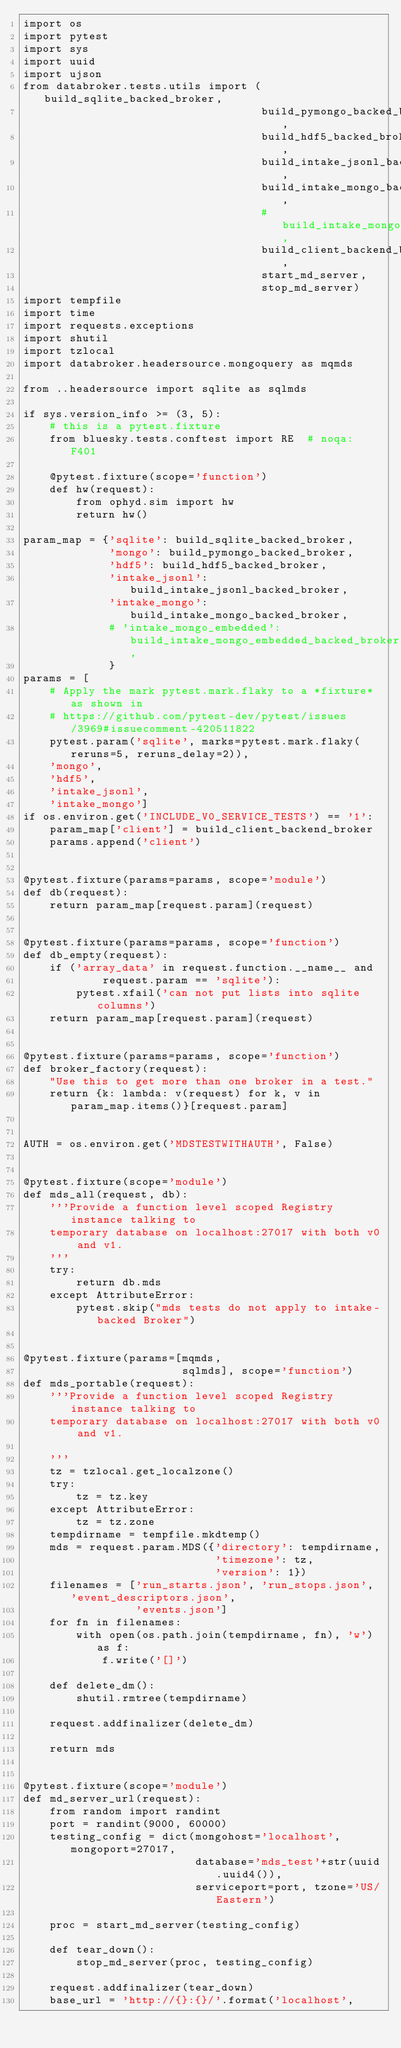<code> <loc_0><loc_0><loc_500><loc_500><_Python_>import os
import pytest
import sys
import uuid
import ujson
from databroker.tests.utils import (build_sqlite_backed_broker,
                                    build_pymongo_backed_broker,
                                    build_hdf5_backed_broker,
                                    build_intake_jsonl_backed_broker,
                                    build_intake_mongo_backed_broker,
                                    # build_intake_mongo_embedded_backed_broker,
                                    build_client_backend_broker,
                                    start_md_server,
                                    stop_md_server)
import tempfile
import time
import requests.exceptions
import shutil
import tzlocal
import databroker.headersource.mongoquery as mqmds

from ..headersource import sqlite as sqlmds

if sys.version_info >= (3, 5):
    # this is a pytest.fixture
    from bluesky.tests.conftest import RE  # noqa: F401

    @pytest.fixture(scope='function')
    def hw(request):
        from ophyd.sim import hw
        return hw()

param_map = {'sqlite': build_sqlite_backed_broker,
             'mongo': build_pymongo_backed_broker,
             'hdf5': build_hdf5_backed_broker,
             'intake_jsonl': build_intake_jsonl_backed_broker,
             'intake_mongo': build_intake_mongo_backed_broker,
             # 'intake_mongo_embedded': build_intake_mongo_embedded_backed_broker,
             }
params = [
    # Apply the mark pytest.mark.flaky to a *fixture* as shown in
    # https://github.com/pytest-dev/pytest/issues/3969#issuecomment-420511822
    pytest.param('sqlite', marks=pytest.mark.flaky(reruns=5, reruns_delay=2)),
    'mongo',
    'hdf5',
    'intake_jsonl',
    'intake_mongo']
if os.environ.get('INCLUDE_V0_SERVICE_TESTS') == '1':
    param_map['client'] = build_client_backend_broker
    params.append('client')


@pytest.fixture(params=params, scope='module')
def db(request):
    return param_map[request.param](request)


@pytest.fixture(params=params, scope='function')
def db_empty(request):
    if ('array_data' in request.function.__name__ and
            request.param == 'sqlite'):
        pytest.xfail('can not put lists into sqlite columns')
    return param_map[request.param](request)


@pytest.fixture(params=params, scope='function')
def broker_factory(request):
    "Use this to get more than one broker in a test."
    return {k: lambda: v(request) for k, v in param_map.items()}[request.param]


AUTH = os.environ.get('MDSTESTWITHAUTH', False)


@pytest.fixture(scope='module')
def mds_all(request, db):
    '''Provide a function level scoped Registry instance talking to
    temporary database on localhost:27017 with both v0 and v1.
    '''
    try:
        return db.mds
    except AttributeError:
        pytest.skip("mds tests do not apply to intake-backed Broker")


@pytest.fixture(params=[mqmds,
                        sqlmds], scope='function')
def mds_portable(request):
    '''Provide a function level scoped Registry instance talking to
    temporary database on localhost:27017 with both v0 and v1.

    '''
    tz = tzlocal.get_localzone()
    try:
        tz = tz.key
    except AttributeError:
        tz = tz.zone
    tempdirname = tempfile.mkdtemp()
    mds = request.param.MDS({'directory': tempdirname,
                             'timezone': tz,
                             'version': 1})
    filenames = ['run_starts.json', 'run_stops.json', 'event_descriptors.json',
                 'events.json']
    for fn in filenames:
        with open(os.path.join(tempdirname, fn), 'w') as f:
            f.write('[]')

    def delete_dm():
        shutil.rmtree(tempdirname)

    request.addfinalizer(delete_dm)

    return mds


@pytest.fixture(scope='module')
def md_server_url(request):
    from random import randint
    port = randint(9000, 60000)
    testing_config = dict(mongohost='localhost', mongoport=27017,
                          database='mds_test'+str(uuid.uuid4()),
                          serviceport=port, tzone='US/Eastern')

    proc = start_md_server(testing_config)

    def tear_down():
        stop_md_server(proc, testing_config)

    request.addfinalizer(tear_down)
    base_url = 'http://{}:{}/'.format('localhost',</code> 